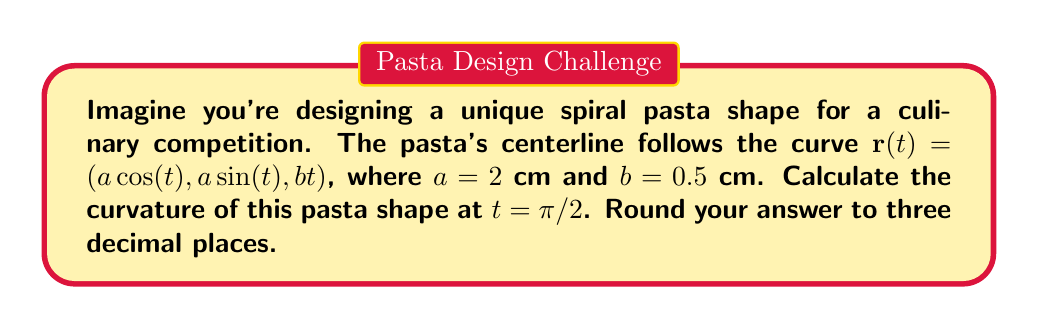Can you solve this math problem? Let's approach this step-by-step:

1) The curvature $\kappa$ of a space curve $\mathbf{r}(t)$ is given by:

   $$\kappa = \frac{|\mathbf{r}'(t) \times \mathbf{r}''(t)|}{|\mathbf{r}'(t)|^3}$$

2) First, let's find $\mathbf{r}'(t)$:
   $$\mathbf{r}'(t) = (-a\sin(t), a\cos(t), b)$$

3) Now, let's find $\mathbf{r}''(t)$:
   $$\mathbf{r}''(t) = (-a\cos(t), -a\sin(t), 0)$$

4) We need to calculate the cross product $\mathbf{r}'(t) \times \mathbf{r}''(t)$:
   $$\mathbf{r}'(t) \times \mathbf{r}''(t) = (ab\sin(t), -ab\cos(t), a^2)$$

5) The magnitude of this cross product is:
   $$|\mathbf{r}'(t) \times \mathbf{r}''(t)| = \sqrt{(ab\sin(t))^2 + (-ab\cos(t))^2 + (a^2)^2} = \sqrt{a^2b^2 + a^4}$$

6) The magnitude of $\mathbf{r}'(t)$ is:
   $$|\mathbf{r}'(t)| = \sqrt{a^2\sin^2(t) + a^2\cos^2(t) + b^2} = \sqrt{a^2 + b^2}$$

7) Substituting these into the curvature formula:
   $$\kappa = \frac{\sqrt{a^2b^2 + a^4}}{(a^2 + b^2)^{3/2}}$$

8) Now, let's substitute the values $a = 2$ and $b = 0.5$:
   $$\kappa = \frac{\sqrt{2^2(0.5)^2 + 2^4}}{(2^2 + 0.5^2)^{3/2}} = \frac{\sqrt{1 + 16}}{(4 + 0.25)^{3/2}} = \frac{\sqrt{17}}{4.25^{3/2}}$$

9) Calculating this and rounding to three decimal places:
   $$\kappa \approx 0.471$$

Note that this curvature is constant for all $t$, including $t = \pi/2$.
Answer: $0.471$ cm$^{-1}$ 